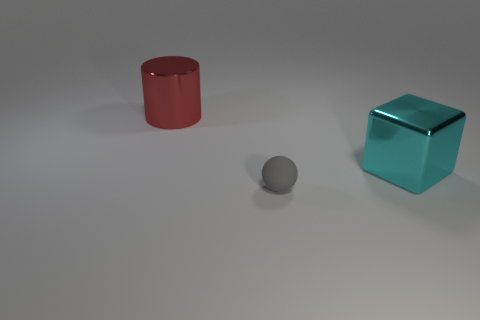If this was part of a larger design, what themes or concepts could it represent? If part of a larger design, these objects could represent themes like minimalism due to the simplicity of shapes and colors, or they could symbolize structural elements in abstract art. The varied shapes and colors might also suggest concepts of diversity and individuality within a unified space. 